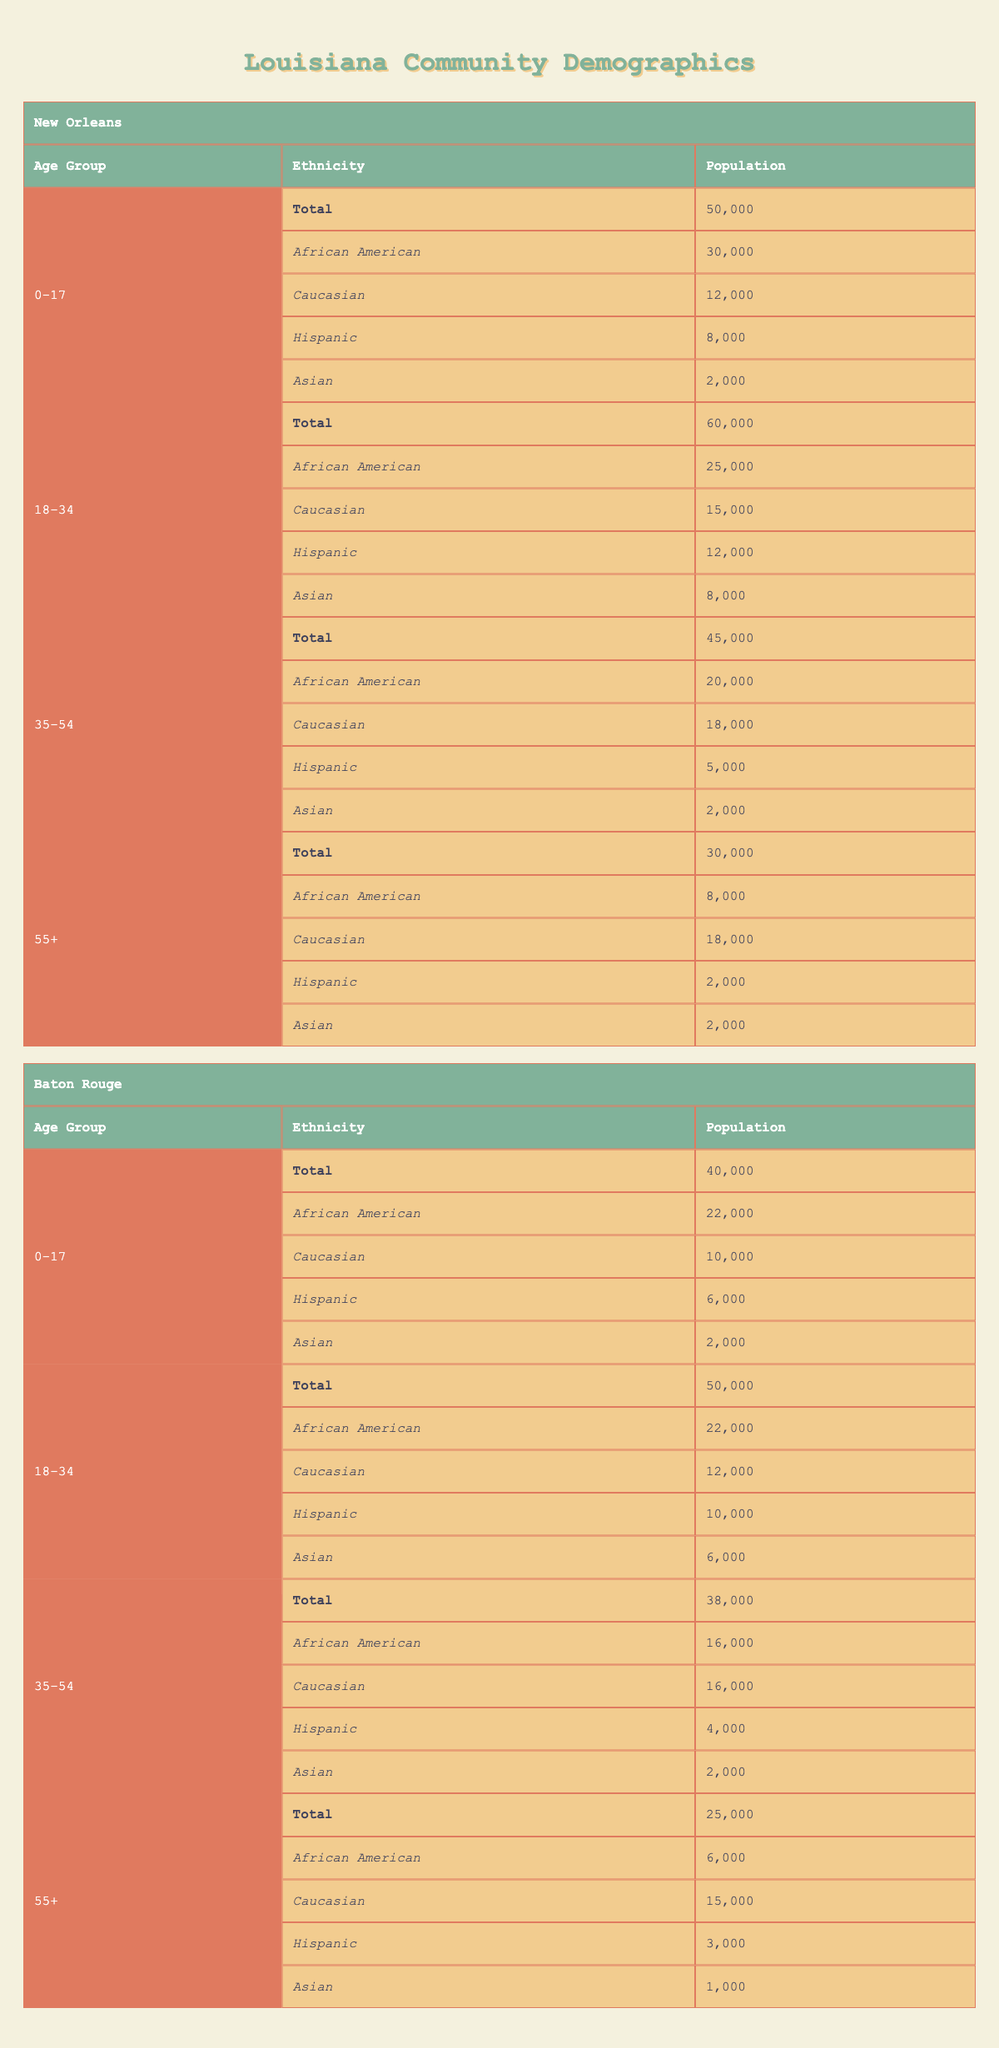What is the total population of 18-34 age group in New Orleans? Referring to the table and looking under New Orleans, the total population for the 18-34 age group is provided directly. It states "Total" under the "18-34" age group is 60,000.
Answer: 60000 How many Hispanic community members are there in Baton Rouge aged 35-54? Looking at the Baton Rouge section and then the 35-54 age group, the Hispanic population is listed as 4,000.
Answer: 4000 Which city has a higher total population in the 0-17 age group, New Orleans or Baton Rouge? New Orleans has a total of 50,000 in the 0-17 age group and Baton Rouge has 40,000 in the same age group. Comparing these numbers shows that New Orleans has a higher total.
Answer: New Orleans What percentage of the total population in New Orleans aged 55+ are Asian? In New Orleans, the total for the 55+ age group is 30,000, and the Asian population in that group is 2,000. To find the percentage, calculate (2000 / 30000) * 100, which equals approximately 6.67%.
Answer: 6.67% Is the number of Caucasian members in Baton Rouge aged 18-34 less than 15,000? In the Baton Rouge section, the 18-34 age group has a population of Caucasian members listed as 12,000, which is less than 15,000. Hence, this statement is true.
Answer: Yes What is the total population of African American members in 35-54 age group across both cities combined? First, find the African American population in the 35-54 age group for each city: New Orleans has 20,000, and Baton Rouge has 16,000. Summing these gives 20,000 + 16,000 = 36,000.
Answer: 36000 Are there more Asian community members in the 55+ age group of New Orleans than Baton Rouge? In New Orleans, the Asian population in the 55+ age group is 2,000, while in Baton Rouge it is 1,000. Since 2,000 is more than 1,000, the answer is yes.
Answer: Yes What is the total population of the Hispanic group in both cities for the age group 18-34? The Hispanic population in New Orleans aged 18-34 is 12,000, while in Baton Rouge it is 10,000. Adding these gives 12,000 + 10,000 = 22,000.
Answer: 22000 